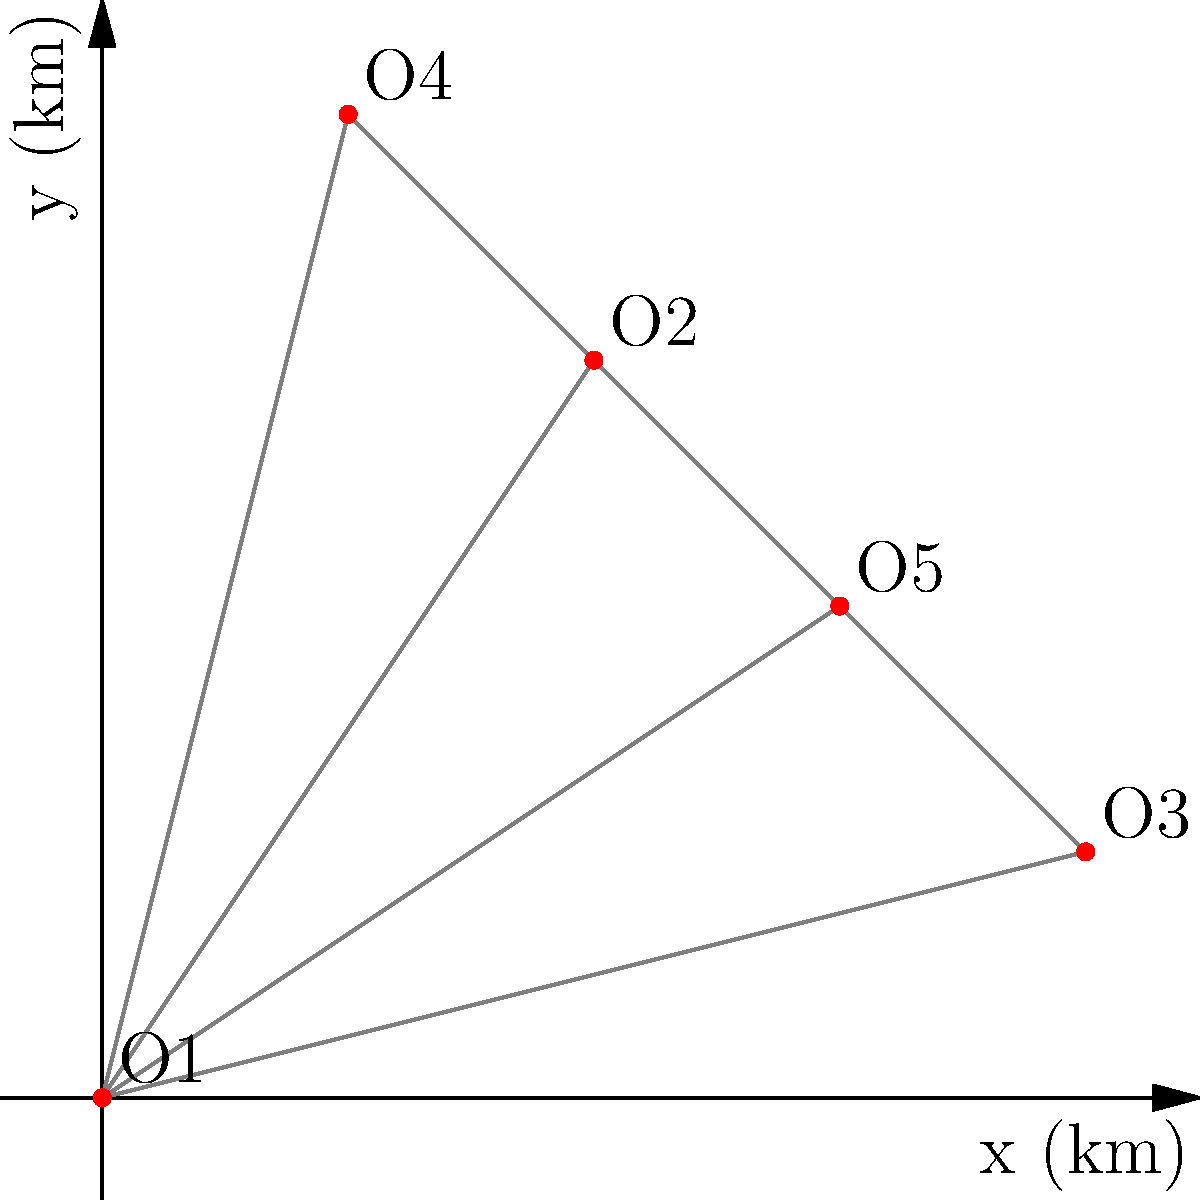A corporation has 5 office locations represented by points O1(0,0), O2(2,3), O3(4,1), O4(1,4), and O5(3,2) on a coordinate plane where each unit represents 1 km. To optimize the network for efficient data transfer, they need to implement a minimum spanning tree. What is the total length of cable required to connect all offices in the minimum spanning tree, rounded to two decimal places? To solve this problem, we'll use Kruskal's algorithm to find the minimum spanning tree:

1. Calculate distances between all pairs of offices:
   O1-O2: $\sqrt{2^2 + 3^2} = \sqrt{13}$
   O1-O3: $\sqrt{4^2 + 1^2} = \sqrt{17}$
   O1-O4: $\sqrt{1^2 + 4^2} = \sqrt{17}$
   O1-O5: $\sqrt{3^2 + 2^2} = \sqrt{13}$
   O2-O3: $\sqrt{2^2 + (-2)^2} = \sqrt{8}$
   O2-O4: $\sqrt{(-1)^2 + 1^2} = \sqrt{2}$
   O2-O5: $\sqrt{1^2 + (-1)^2} = \sqrt{2}$
   O3-O4: $\sqrt{(-3)^2 + 3^2} = 3\sqrt{2}$
   O3-O5: $\sqrt{(-1)^2 + 1^2} = \sqrt{2}$
   O4-O5: $\sqrt{2^2 + (-2)^2} = \sqrt{8}$

2. Sort distances in ascending order:
   O2-O4: $\sqrt{2}$
   O2-O5: $\sqrt{2}$
   O3-O5: $\sqrt{2}$
   O2-O3: $\sqrt{8}$
   O4-O5: $\sqrt{8}$
   O1-O2: $\sqrt{13}$
   O1-O5: $\sqrt{13}$

3. Add edges to the tree, avoiding cycles:
   O2-O4: $\sqrt{2}$
   O2-O5: $\sqrt{2}$
   O3-O5: $\sqrt{2}$
   O1-O2: $\sqrt{13}$

4. Sum the lengths of the selected edges:
   Total length = $\sqrt{2} + \sqrt{2} + \sqrt{2} + \sqrt{13}$
                = $3\sqrt{2} + \sqrt{13}$
                ≈ 7.8284 km

5. Round to two decimal places: 7.83 km
Answer: 7.83 km 